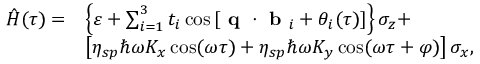Convert formula to latex. <formula><loc_0><loc_0><loc_500><loc_500>\begin{array} { r l } { \hat { H } ( \tau ) = } & { \left \{ \varepsilon + \sum _ { i = 1 } ^ { 3 } t _ { i } \cos \left [ q \cdot b _ { i } + \theta _ { i } ( \tau ) \right ] \right \} \sigma _ { z } + } \\ & { \left [ \eta _ { s p } \hbar { \omega } K _ { x } \cos ( \omega \tau ) + \eta _ { s p } \hbar { \omega } K _ { y } \cos ( \omega \tau + \varphi ) \right ] \sigma _ { x } , } \end{array}</formula> 